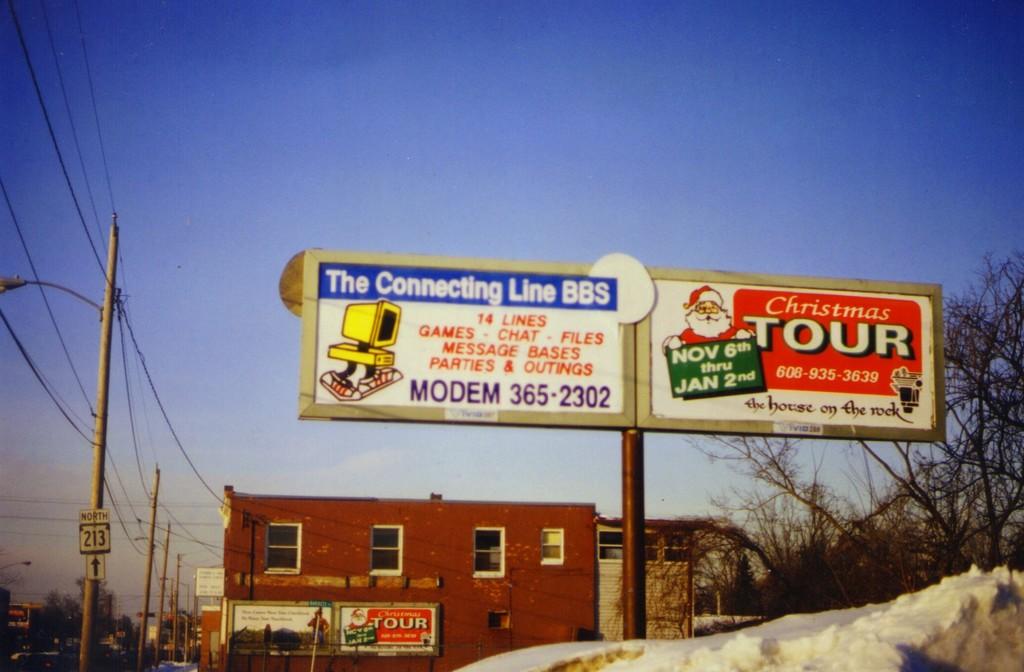When is santa in town for his christmas tour?
Offer a terse response. Nov 6th thru jan 2nd. What is the phone number for the connecting line bbs?
Provide a succinct answer. 365-2302. 